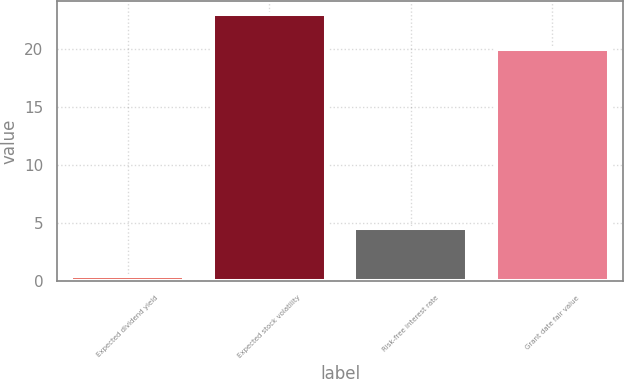Convert chart. <chart><loc_0><loc_0><loc_500><loc_500><bar_chart><fcel>Expected dividend yield<fcel>Expected stock volatility<fcel>Risk-free interest rate<fcel>Grant date fair value<nl><fcel>0.44<fcel>23<fcel>4.59<fcel>19.97<nl></chart> 